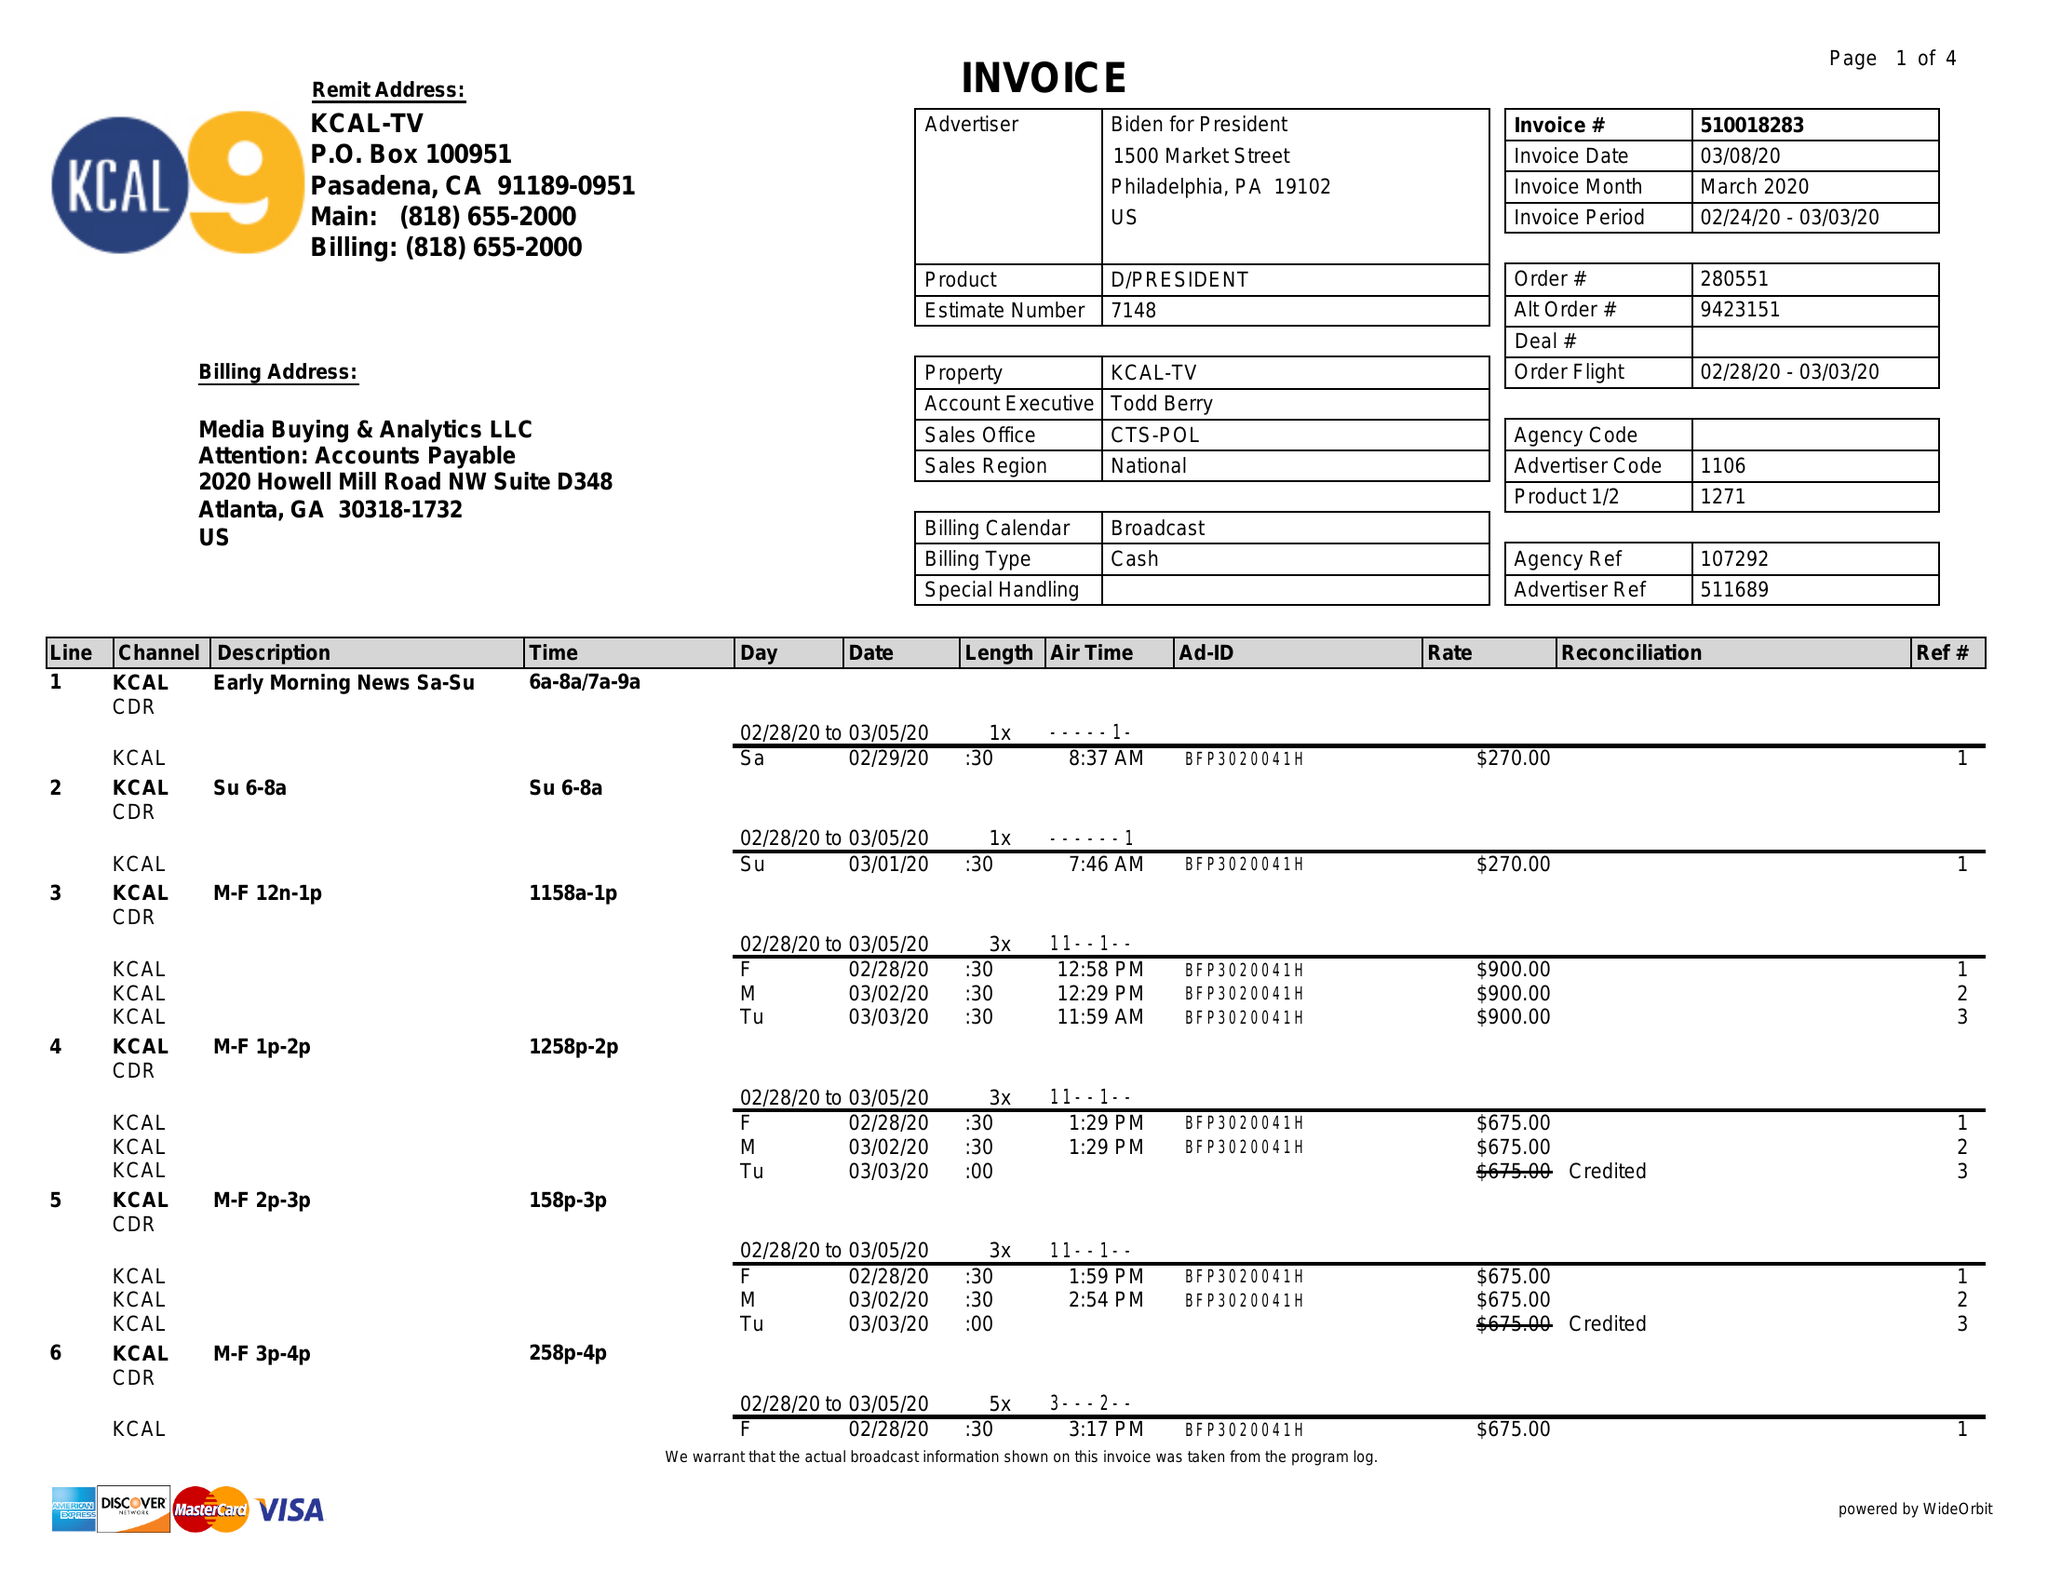What is the value for the contract_num?
Answer the question using a single word or phrase. 510018283 